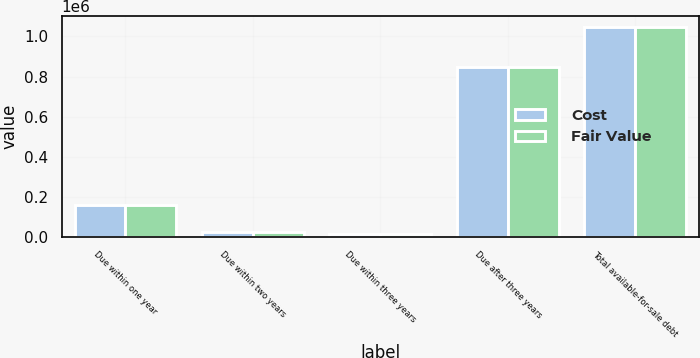<chart> <loc_0><loc_0><loc_500><loc_500><stacked_bar_chart><ecel><fcel>Due within one year<fcel>Due within two years<fcel>Due within three years<fcel>Due after three years<fcel>Total available-for-sale debt<nl><fcel>Cost<fcel>159564<fcel>25856<fcel>14700<fcel>848523<fcel>1.04864e+06<nl><fcel>Fair Value<fcel>159488<fcel>25808<fcel>14700<fcel>848474<fcel>1.04847e+06<nl></chart> 